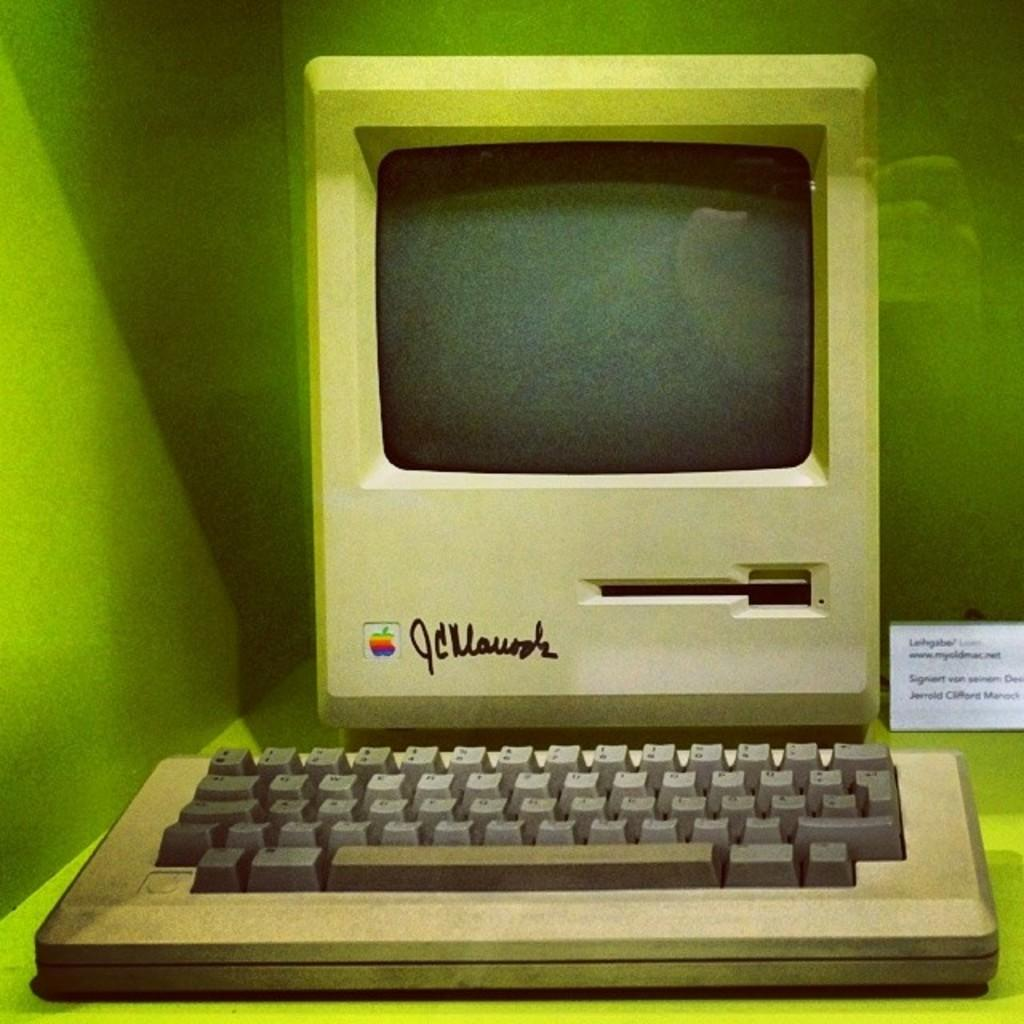<image>
Give a short and clear explanation of the subsequent image. A vintage apple computer with Apple logo and signed by JC Mauricia. 